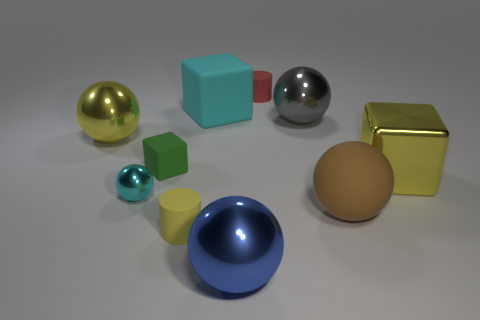Is there a tiny ball? Yes, there is a small turquoise ball located near the front of the image, among other objects of various shapes and colors. 